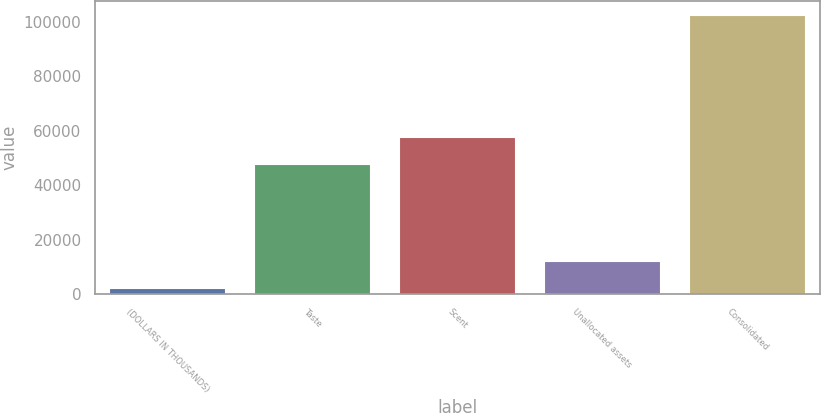Convert chart. <chart><loc_0><loc_0><loc_500><loc_500><bar_chart><fcel>(DOLLARS IN THOUSANDS)<fcel>Taste<fcel>Scent<fcel>Unallocated assets<fcel>Consolidated<nl><fcel>2016<fcel>47705<fcel>57750.3<fcel>12061.3<fcel>102469<nl></chart> 